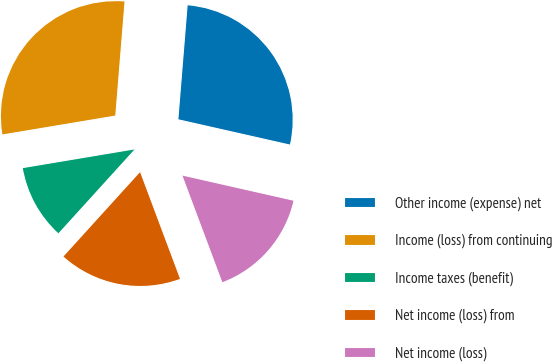<chart> <loc_0><loc_0><loc_500><loc_500><pie_chart><fcel>Other income (expense) net<fcel>Income (loss) from continuing<fcel>Income taxes (benefit)<fcel>Net income (loss) from<fcel>Net income (loss)<nl><fcel>27.25%<fcel>28.93%<fcel>10.63%<fcel>17.43%<fcel>15.76%<nl></chart> 